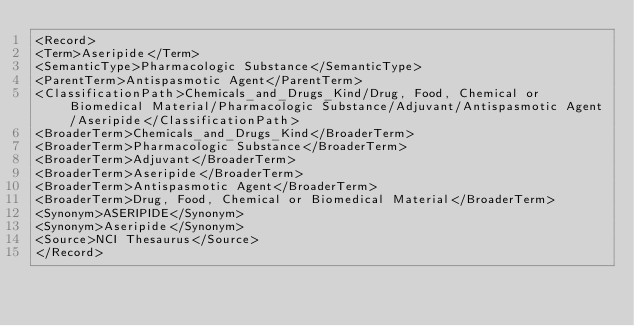<code> <loc_0><loc_0><loc_500><loc_500><_XML_><Record>
<Term>Aseripide</Term>
<SemanticType>Pharmacologic Substance</SemanticType>
<ParentTerm>Antispasmotic Agent</ParentTerm>
<ClassificationPath>Chemicals_and_Drugs_Kind/Drug, Food, Chemical or Biomedical Material/Pharmacologic Substance/Adjuvant/Antispasmotic Agent/Aseripide</ClassificationPath>
<BroaderTerm>Chemicals_and_Drugs_Kind</BroaderTerm>
<BroaderTerm>Pharmacologic Substance</BroaderTerm>
<BroaderTerm>Adjuvant</BroaderTerm>
<BroaderTerm>Aseripide</BroaderTerm>
<BroaderTerm>Antispasmotic Agent</BroaderTerm>
<BroaderTerm>Drug, Food, Chemical or Biomedical Material</BroaderTerm>
<Synonym>ASERIPIDE</Synonym>
<Synonym>Aseripide</Synonym>
<Source>NCI Thesaurus</Source>
</Record>
</code> 